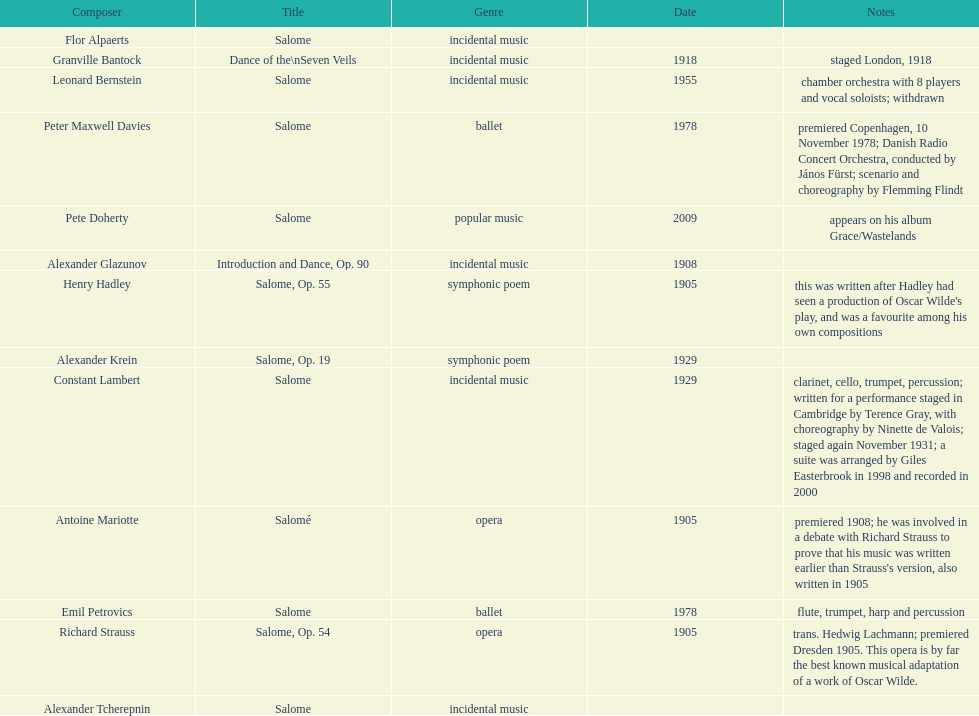Help me parse the entirety of this table. {'header': ['Composer', 'Title', 'Genre', 'Date', 'Notes'], 'rows': [['Flor Alpaerts', 'Salome', 'incidental\xa0music', '', ''], ['Granville Bantock', 'Dance of the\\nSeven Veils', 'incidental music', '1918', 'staged London, 1918'], ['Leonard Bernstein', 'Salome', 'incidental music', '1955', 'chamber orchestra with 8 players and vocal soloists; withdrawn'], ['Peter\xa0Maxwell\xa0Davies', 'Salome', 'ballet', '1978', 'premiered Copenhagen, 10 November 1978; Danish Radio Concert Orchestra, conducted by János Fürst; scenario and choreography by Flemming Flindt'], ['Pete Doherty', 'Salome', 'popular music', '2009', 'appears on his album Grace/Wastelands'], ['Alexander Glazunov', 'Introduction and Dance, Op. 90', 'incidental music', '1908', ''], ['Henry Hadley', 'Salome, Op. 55', 'symphonic poem', '1905', "this was written after Hadley had seen a production of Oscar Wilde's play, and was a favourite among his own compositions"], ['Alexander Krein', 'Salome, Op. 19', 'symphonic poem', '1929', ''], ['Constant Lambert', 'Salome', 'incidental music', '1929', 'clarinet, cello, trumpet, percussion; written for a performance staged in Cambridge by Terence Gray, with choreography by Ninette de Valois; staged again November 1931; a suite was arranged by Giles Easterbrook in 1998 and recorded in 2000'], ['Antoine Mariotte', 'Salomé', 'opera', '1905', "premiered 1908; he was involved in a debate with Richard Strauss to prove that his music was written earlier than Strauss's version, also written in 1905"], ['Emil Petrovics', 'Salome', 'ballet', '1978', 'flute, trumpet, harp and percussion'], ['Richard Strauss', 'Salome, Op. 54', 'opera', '1905', 'trans. Hedwig Lachmann; premiered Dresden 1905. This opera is by far the best known musical adaptation of a work of Oscar Wilde.'], ['Alexander\xa0Tcherepnin', 'Salome', 'incidental music', '', '']]} Which composer published first granville bantock or emil petrovics? Granville Bantock. 